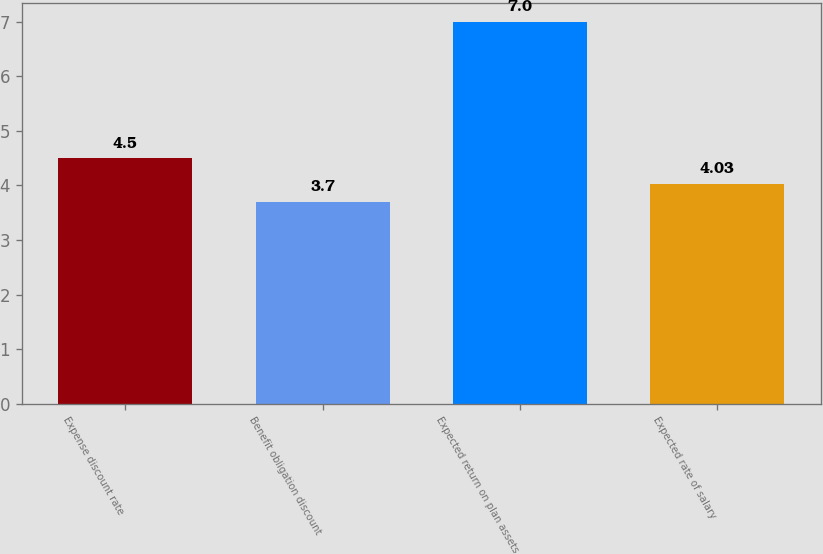Convert chart. <chart><loc_0><loc_0><loc_500><loc_500><bar_chart><fcel>Expense discount rate<fcel>Benefit obligation discount<fcel>Expected return on plan assets<fcel>Expected rate of salary<nl><fcel>4.5<fcel>3.7<fcel>7<fcel>4.03<nl></chart> 